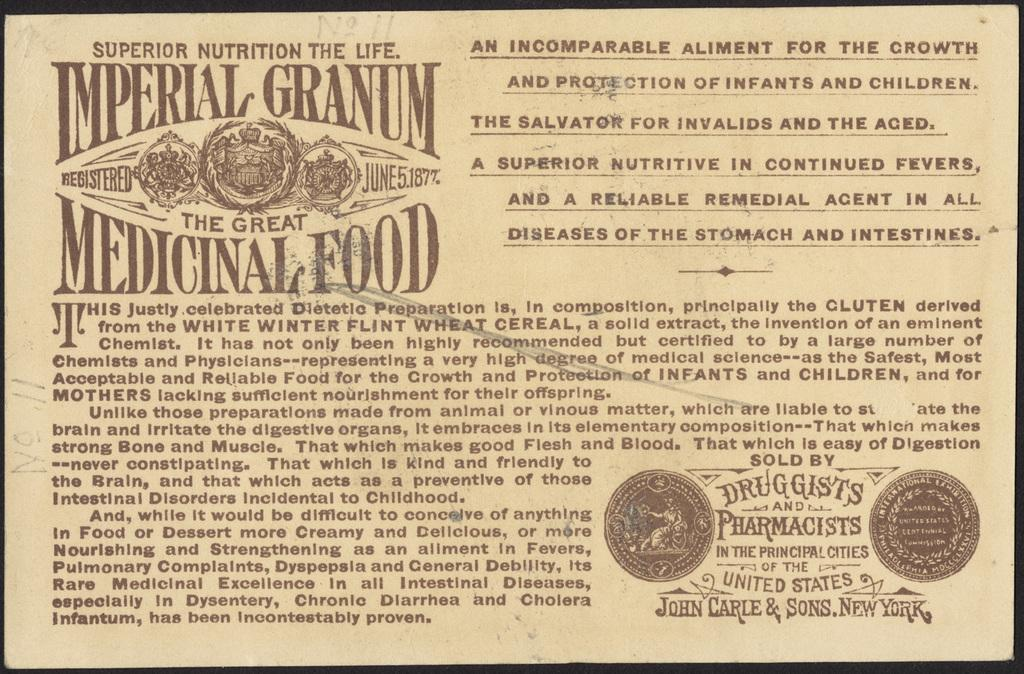Provide a one-sentence caption for the provided image. Imperial granium the great medicinal food certification sign. 